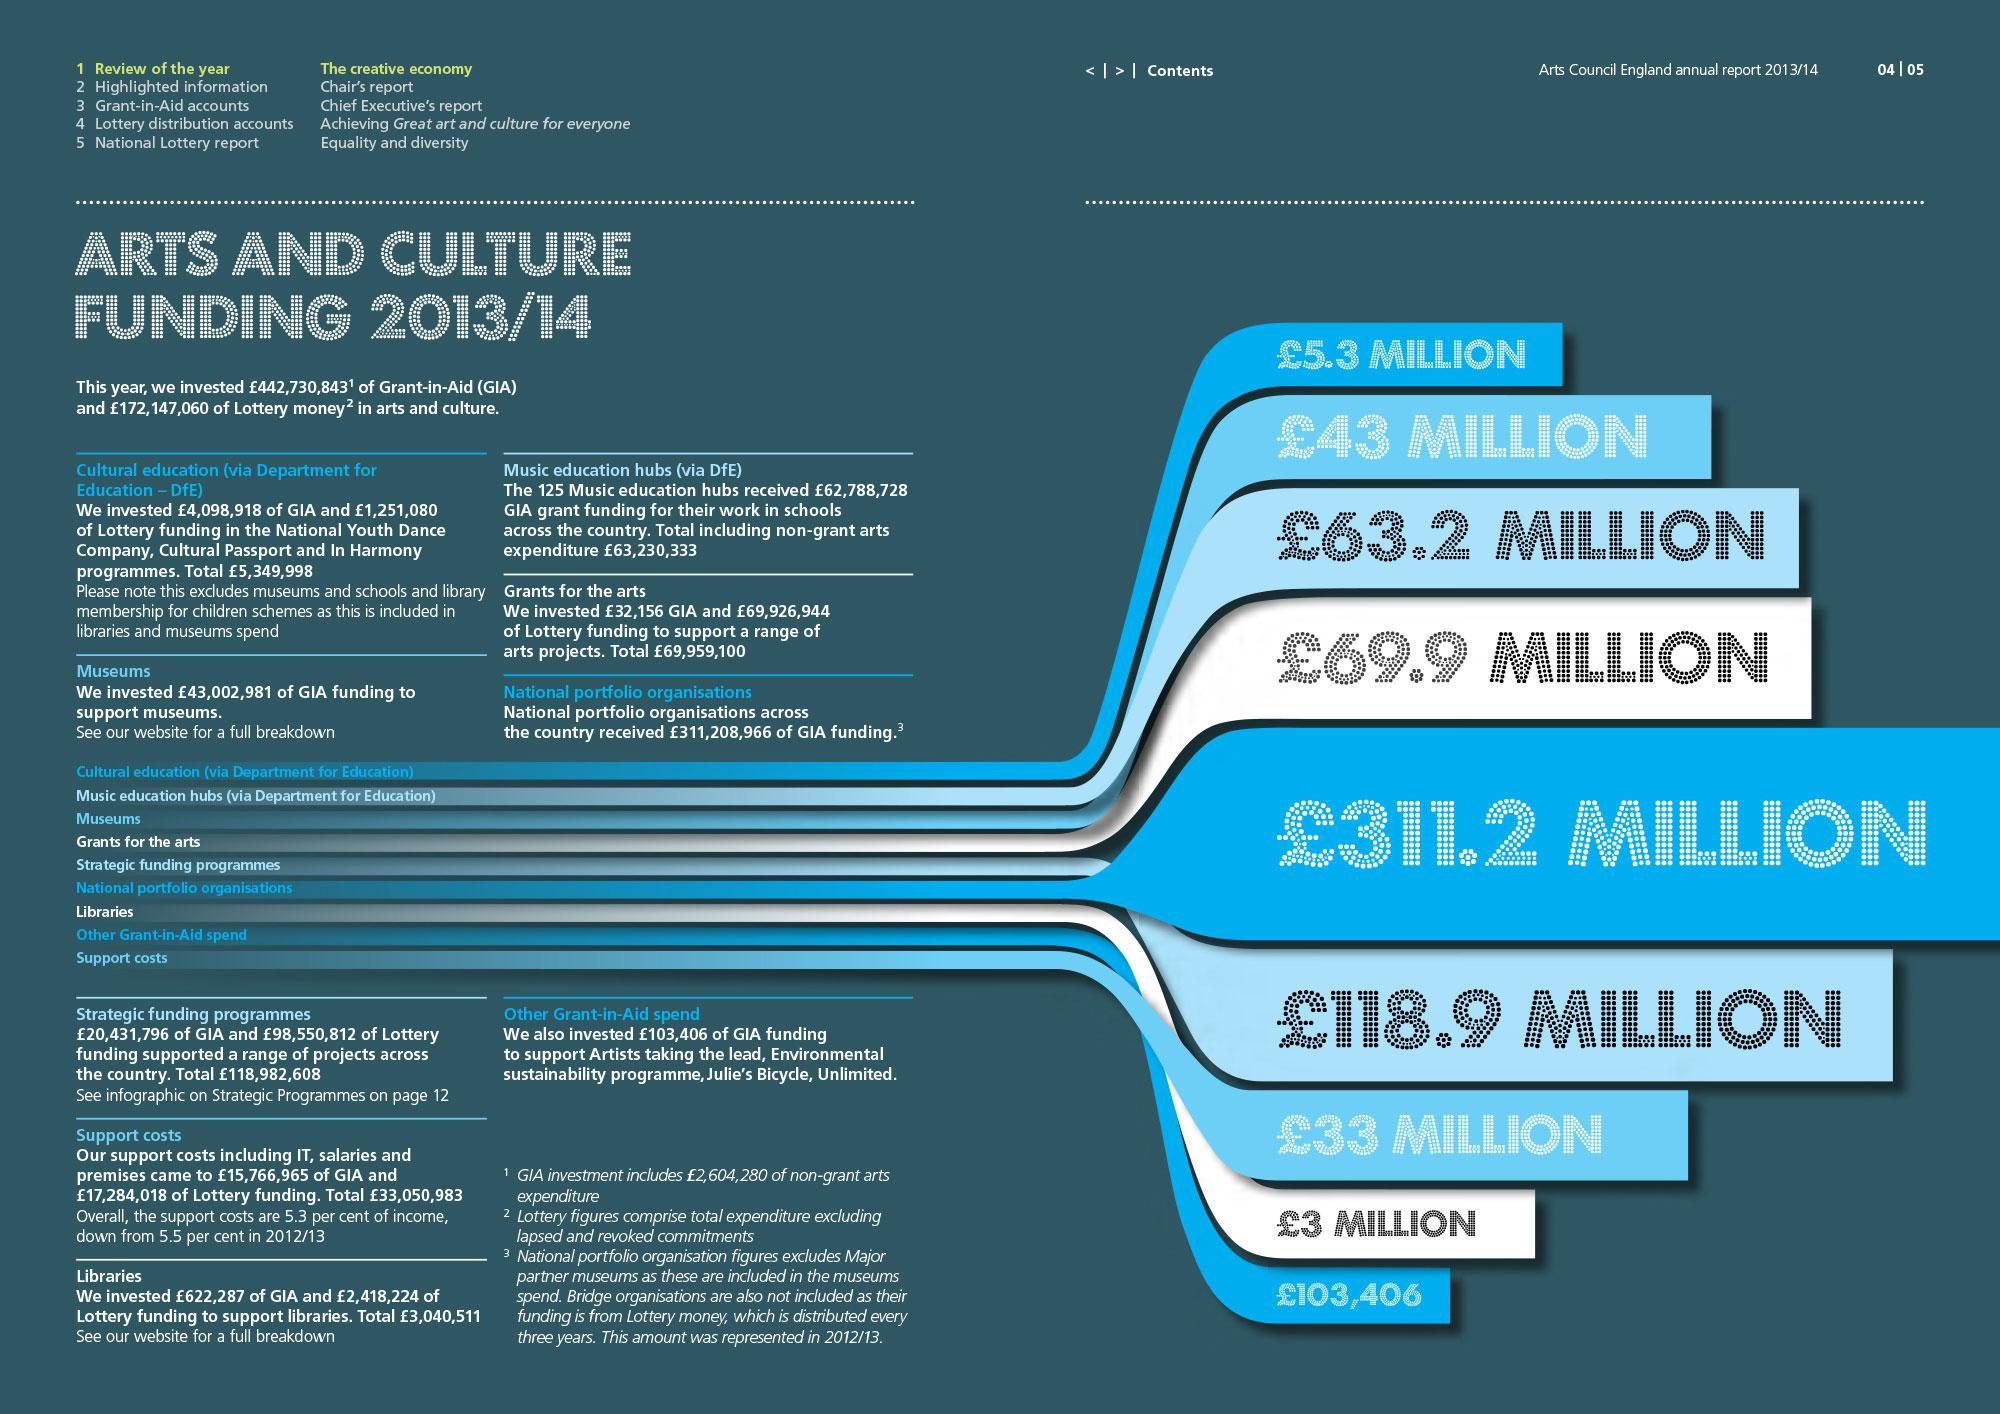Mention a couple of crucial points in this snapshot. According to the provided information, the least amount received in pounds for Arts and Culture funding was 103,406. The amount received towards support costs is 33 million pounds. The total grant received by cultural education and national portfolio organizations in pounds was 316.5 million. The organization that has received 63.2 million pounds is museums. The highest amount received in pounds for Arts and Culture funding was 311.2 million. 